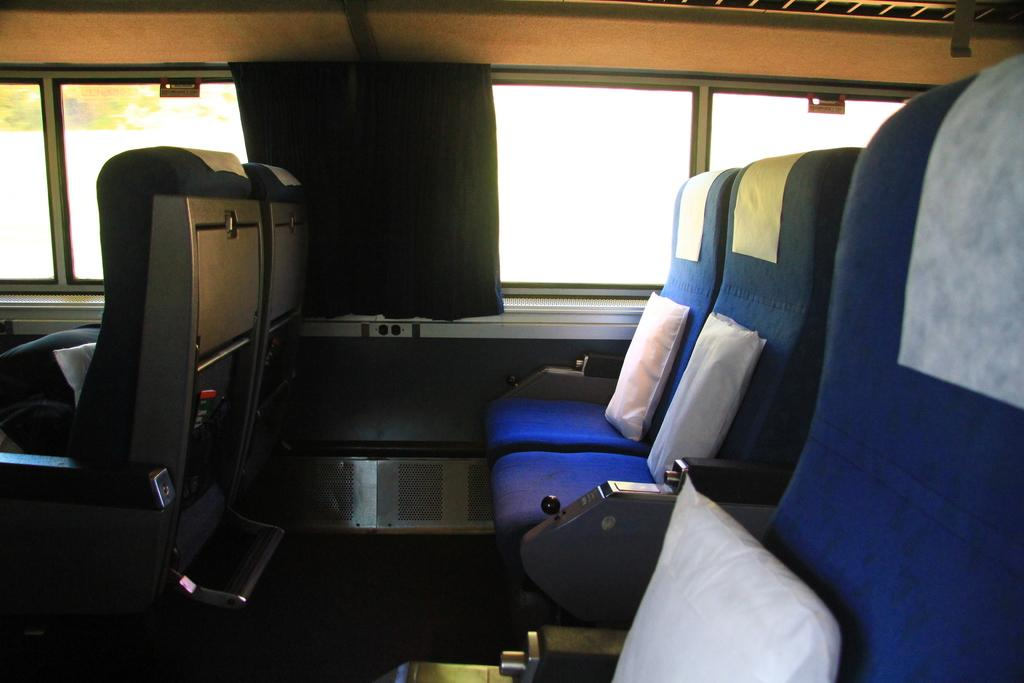Where was the image taken? The image was taken inside a vehicle. How many seats are visible in the vehicle? There are multiple seats in the vehicle. What can be seen through the windows in the background? There are glass windows with curtains in the background. What type of plant is growing near the water in the image? There is no water or plant present in the image; it was taken inside a vehicle with multiple seats and glass windows with curtains in the background. 